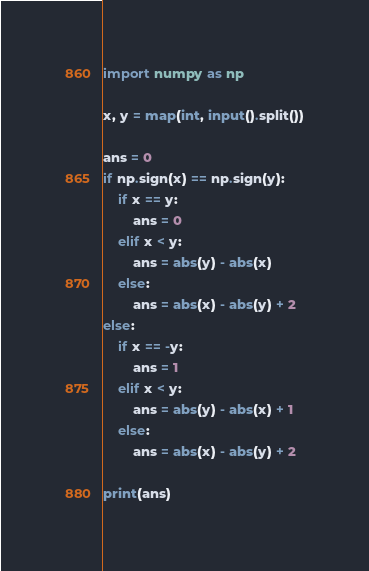Convert code to text. <code><loc_0><loc_0><loc_500><loc_500><_Python_>import numpy as np

x, y = map(int, input().split())

ans = 0
if np.sign(x) == np.sign(y):
    if x == y:
        ans = 0
    elif x < y:
        ans = abs(y) - abs(x)
    else:
        ans = abs(x) - abs(y) + 2
else:
    if x == -y:
        ans = 1
    elif x < y:
        ans = abs(y) - abs(x) + 1
    else:
        ans = abs(x) - abs(y) + 2

print(ans)</code> 